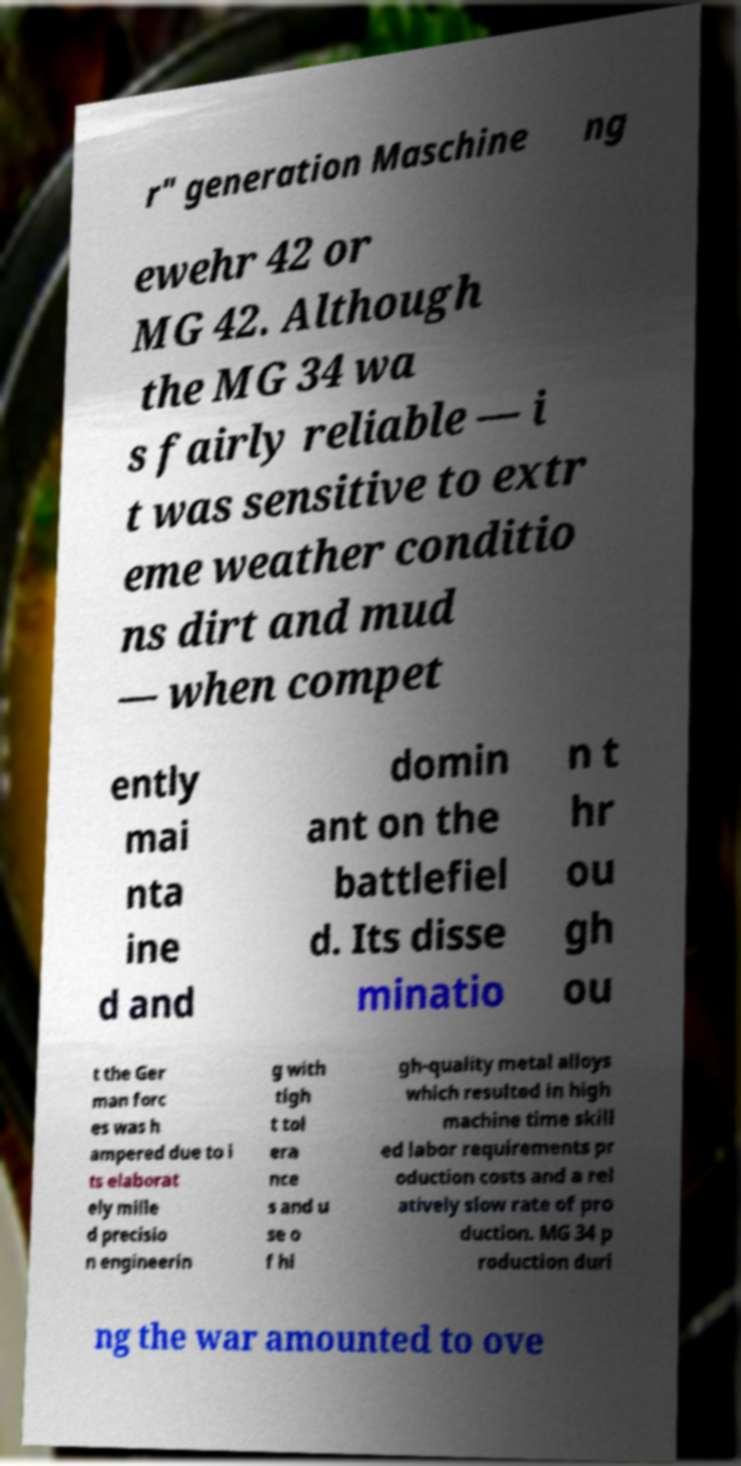There's text embedded in this image that I need extracted. Can you transcribe it verbatim? r" generation Maschine ng ewehr 42 or MG 42. Although the MG 34 wa s fairly reliable — i t was sensitive to extr eme weather conditio ns dirt and mud — when compet ently mai nta ine d and domin ant on the battlefiel d. Its disse minatio n t hr ou gh ou t the Ger man forc es was h ampered due to i ts elaborat ely mille d precisio n engineerin g with tigh t tol era nce s and u se o f hi gh-quality metal alloys which resulted in high machine time skill ed labor requirements pr oduction costs and a rel atively slow rate of pro duction. MG 34 p roduction duri ng the war amounted to ove 